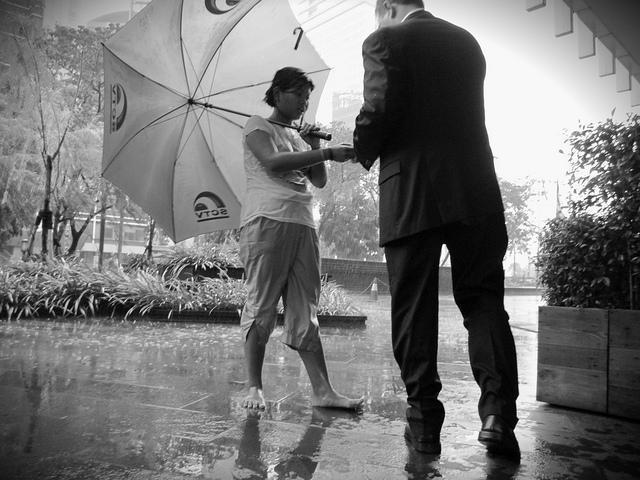How many umbrellas are there?
Give a very brief answer. 1. How many people are there?
Give a very brief answer. 2. 